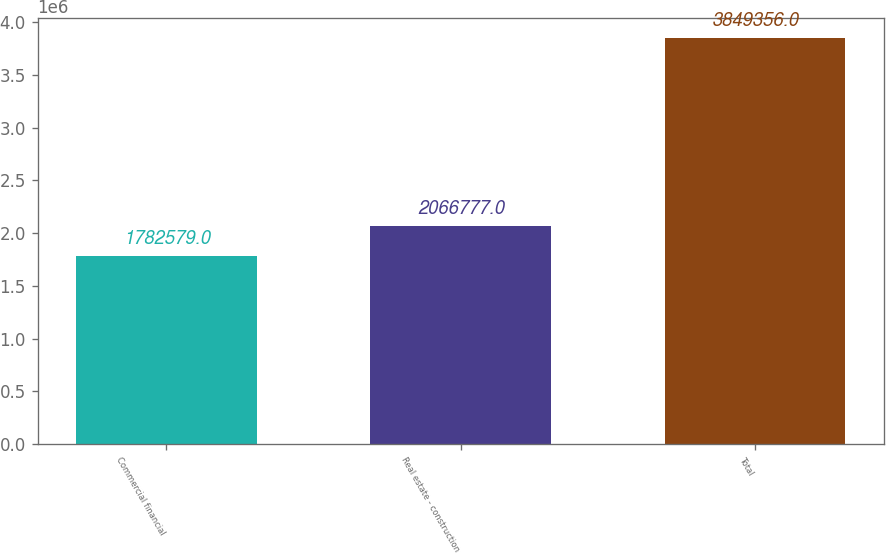Convert chart. <chart><loc_0><loc_0><loc_500><loc_500><bar_chart><fcel>Commercial financial<fcel>Real estate - construction<fcel>Total<nl><fcel>1.78258e+06<fcel>2.06678e+06<fcel>3.84936e+06<nl></chart> 